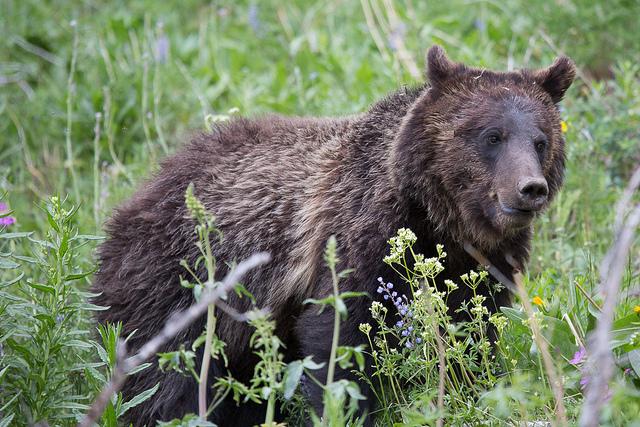Does a bear shit in the woods?
Answer briefly. Yes. Do most bears live in the forest?
Give a very brief answer. Yes. Which color is the animal?
Keep it brief. Brown. Which species of bear is this?
Short answer required. Grizzly. What type of bear is this?
Be succinct. Brown. 